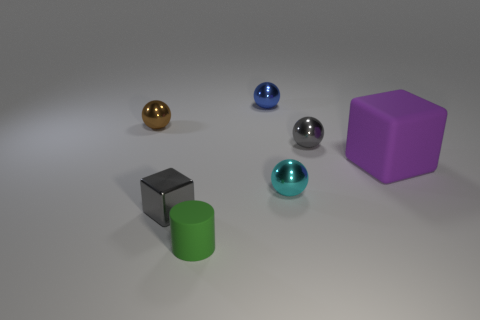What number of things are gray objects in front of the big purple object or tiny things behind the cyan ball? There are two gray objects in front of the big purple object, which are a gray cube and a gray cylinder. Additionally, there are no tiny objects behind the cyan ball. Therefore, the total count of items in question is two. 